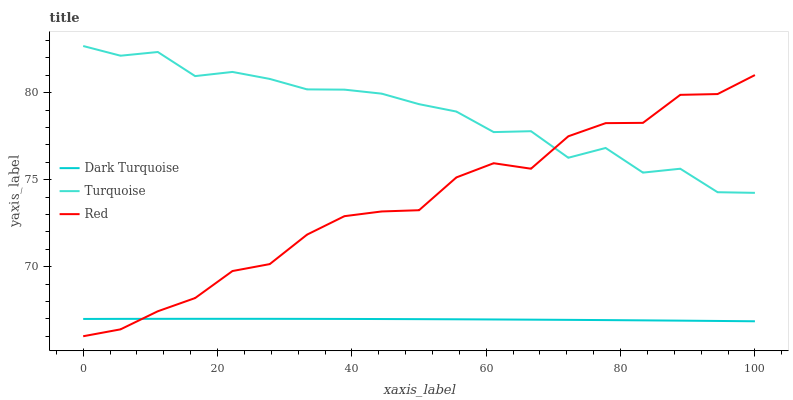Does Red have the minimum area under the curve?
Answer yes or no. No. Does Red have the maximum area under the curve?
Answer yes or no. No. Is Red the smoothest?
Answer yes or no. No. Is Red the roughest?
Answer yes or no. No. Does Turquoise have the lowest value?
Answer yes or no. No. Does Red have the highest value?
Answer yes or no. No. Is Dark Turquoise less than Turquoise?
Answer yes or no. Yes. Is Turquoise greater than Dark Turquoise?
Answer yes or no. Yes. Does Dark Turquoise intersect Turquoise?
Answer yes or no. No. 